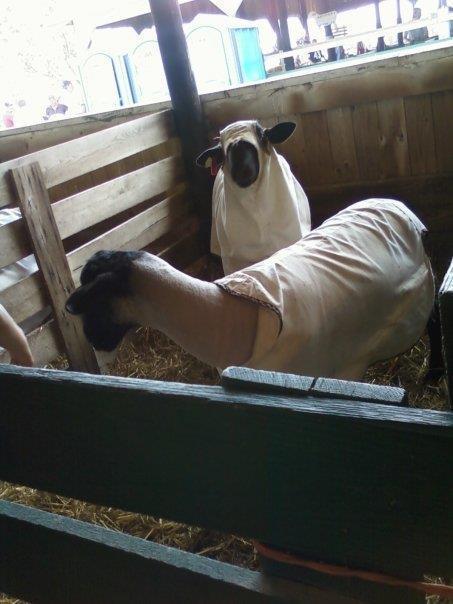How many sheep are there?
Give a very brief answer. 3. 